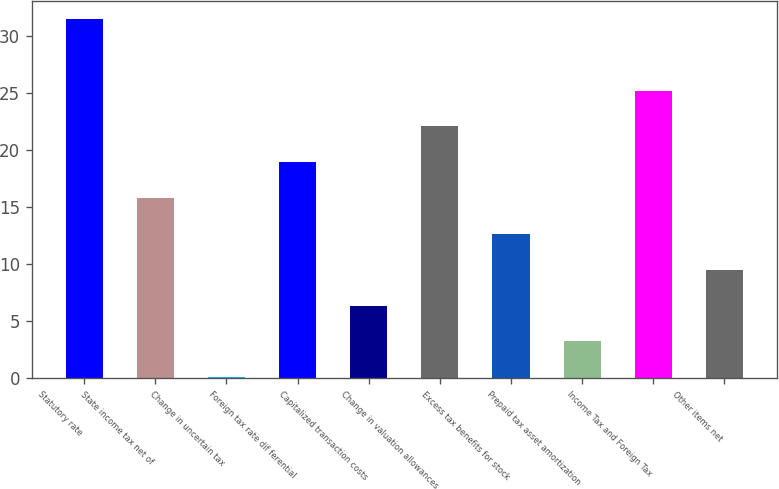Convert chart. <chart><loc_0><loc_0><loc_500><loc_500><bar_chart><fcel>Statutory rate<fcel>State income tax net of<fcel>Change in uncertain tax<fcel>Foreign tax rate dif ferential<fcel>Capitalized transaction costs<fcel>Change in valuation allowances<fcel>Excess tax benefits for stock<fcel>Prepaid tax asset amortization<fcel>Income Tax and Foreign Tax<fcel>Other items net<nl><fcel>31.5<fcel>15.8<fcel>0.1<fcel>18.94<fcel>6.38<fcel>22.08<fcel>12.66<fcel>3.24<fcel>25.22<fcel>9.52<nl></chart> 